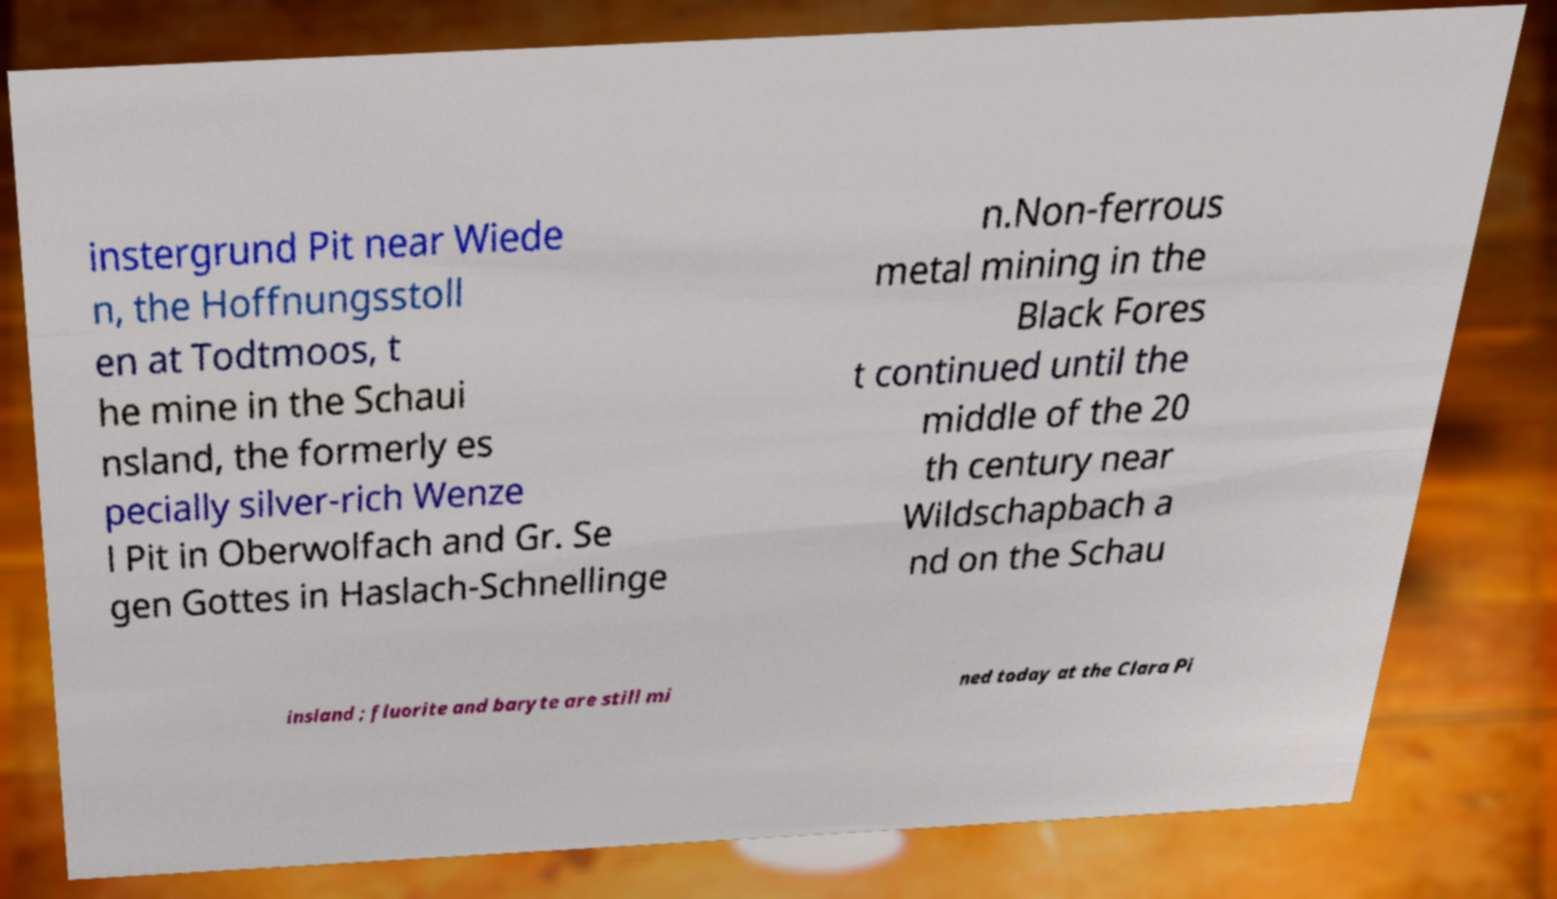Can you read and provide the text displayed in the image?This photo seems to have some interesting text. Can you extract and type it out for me? instergrund Pit near Wiede n, the Hoffnungsstoll en at Todtmoos, t he mine in the Schaui nsland, the formerly es pecially silver-rich Wenze l Pit in Oberwolfach and Gr. Se gen Gottes in Haslach-Schnellinge n.Non-ferrous metal mining in the Black Fores t continued until the middle of the 20 th century near Wildschapbach a nd on the Schau insland ; fluorite and baryte are still mi ned today at the Clara Pi 